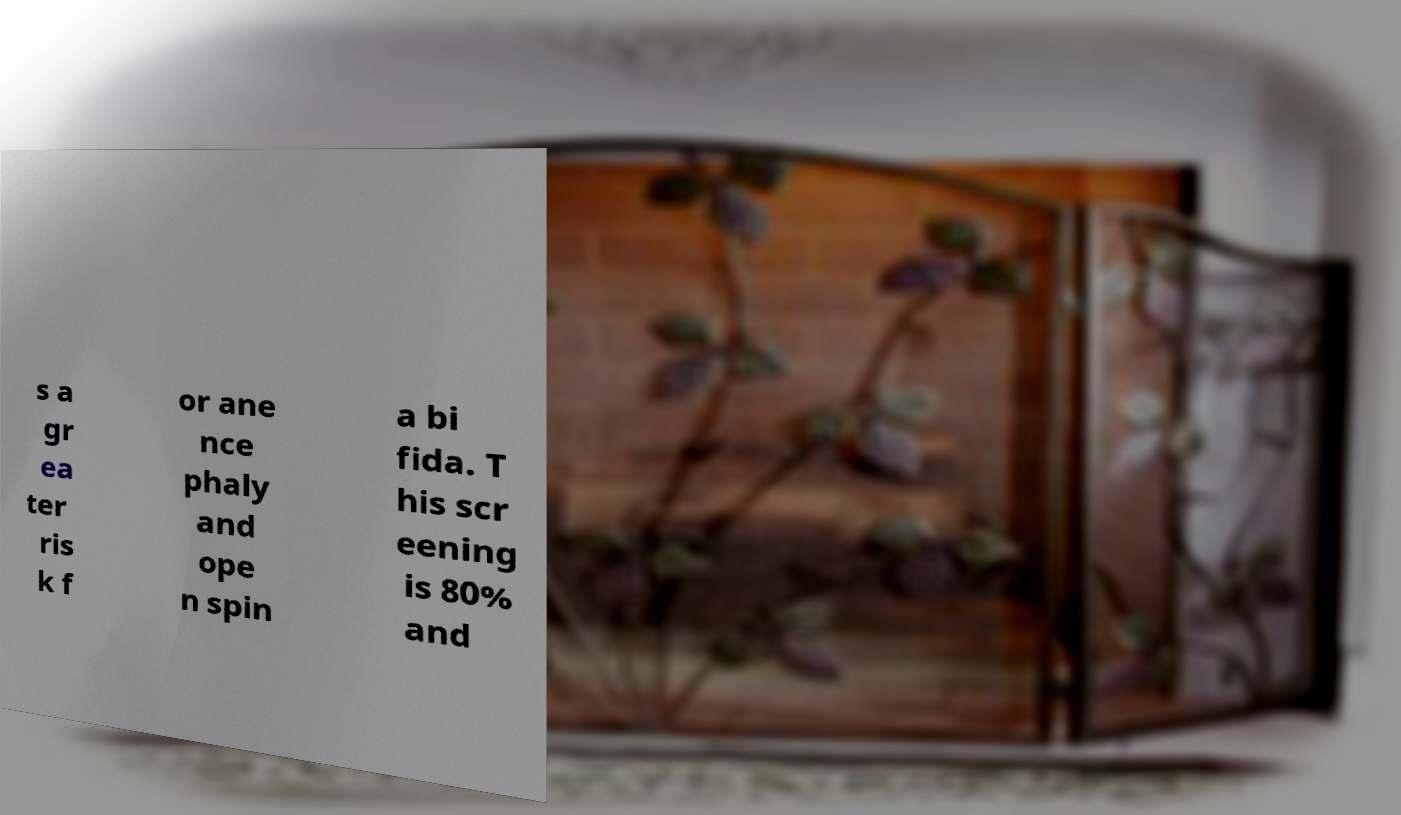There's text embedded in this image that I need extracted. Can you transcribe it verbatim? s a gr ea ter ris k f or ane nce phaly and ope n spin a bi fida. T his scr eening is 80% and 